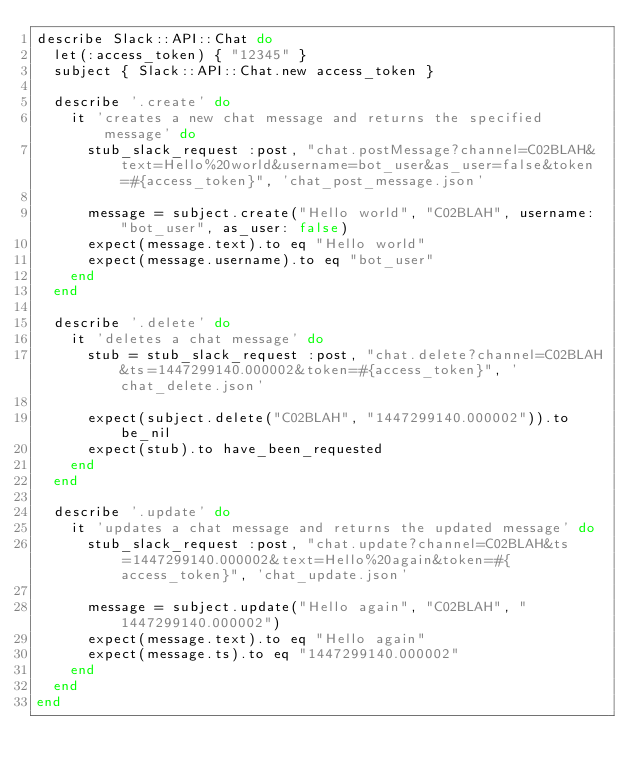<code> <loc_0><loc_0><loc_500><loc_500><_Ruby_>describe Slack::API::Chat do
  let(:access_token) { "12345" }
  subject { Slack::API::Chat.new access_token }

  describe '.create' do
    it 'creates a new chat message and returns the specified message' do
      stub_slack_request :post, "chat.postMessage?channel=C02BLAH&text=Hello%20world&username=bot_user&as_user=false&token=#{access_token}", 'chat_post_message.json'

      message = subject.create("Hello world", "C02BLAH", username: "bot_user", as_user: false)
      expect(message.text).to eq "Hello world"
      expect(message.username).to eq "bot_user"
    end
  end

  describe '.delete' do
    it 'deletes a chat message' do
      stub = stub_slack_request :post, "chat.delete?channel=C02BLAH&ts=1447299140.000002&token=#{access_token}", 'chat_delete.json'

      expect(subject.delete("C02BLAH", "1447299140.000002")).to be_nil
      expect(stub).to have_been_requested
    end
  end

  describe '.update' do
    it 'updates a chat message and returns the updated message' do
      stub_slack_request :post, "chat.update?channel=C02BLAH&ts=1447299140.000002&text=Hello%20again&token=#{access_token}", 'chat_update.json'

      message = subject.update("Hello again", "C02BLAH", "1447299140.000002")
      expect(message.text).to eq "Hello again"
      expect(message.ts).to eq "1447299140.000002"
    end
  end
end
</code> 